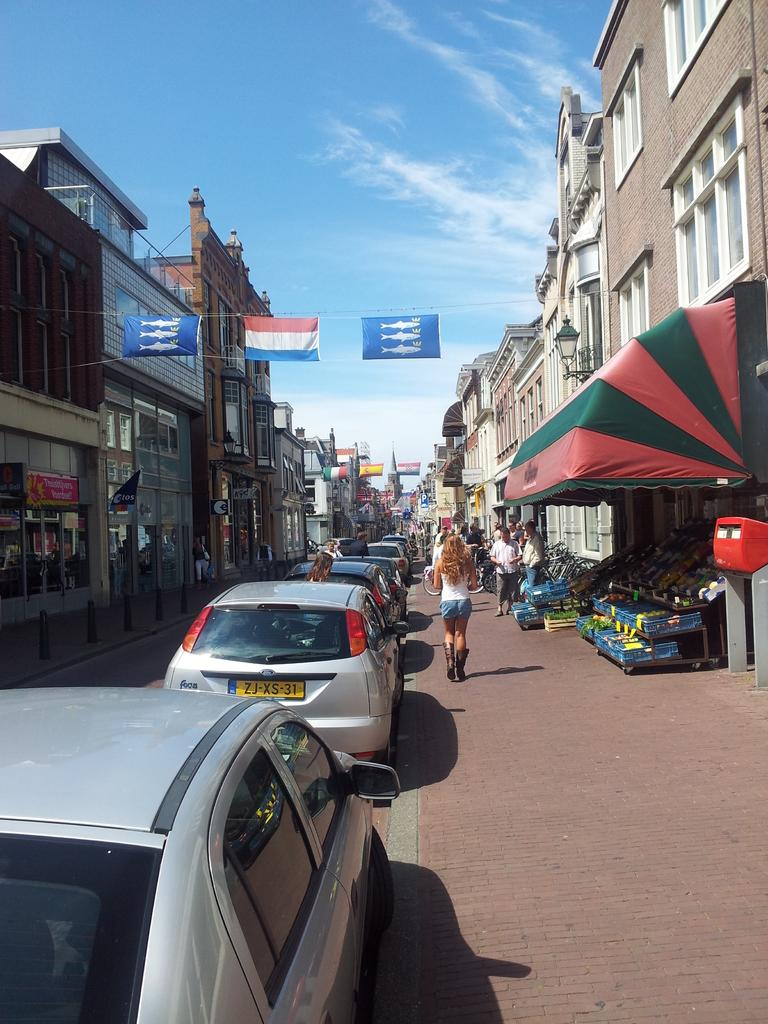What can be seen in large numbers in the image? There are many vehicles and people in the image. What structures are visible on both sides of the image? There are buildings on both sides of the image. What decorations can be seen in the image? Flags are hanged in the image. What is visible in the background of the image? There is sky visible in the background of the image, and clouds are present in the sky. What type of cap is being worn by the oatmeal in the image? There is no oatmeal or cap present in the image. What type of work is being done by the people in the image? The image does not provide information about the type of work being done by the people. 